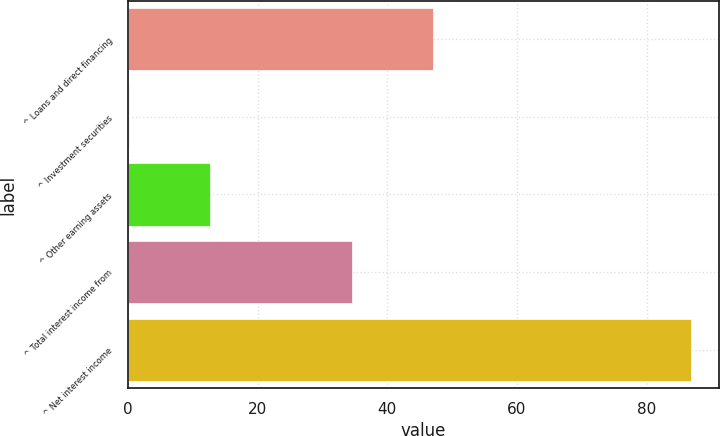Convert chart. <chart><loc_0><loc_0><loc_500><loc_500><bar_chart><fcel>^ Loans and direct financing<fcel>^ Investment securities<fcel>^ Other earning assets<fcel>^ Total interest income from<fcel>^ Net interest income<nl><fcel>47<fcel>0.2<fcel>12.7<fcel>34.5<fcel>86.8<nl></chart> 